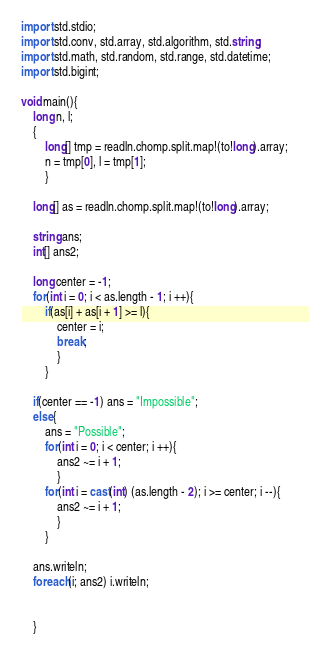Convert code to text. <code><loc_0><loc_0><loc_500><loc_500><_D_>import std.stdio;
import std.conv, std.array, std.algorithm, std.string;
import std.math, std.random, std.range, std.datetime;
import std.bigint;

void main(){
	long n, l;
	{
		long[] tmp = readln.chomp.split.map!(to!long).array;
		n = tmp[0], l = tmp[1];
		}
	
	long[] as = readln.chomp.split.map!(to!long).array;
	
	string ans;
	int[] ans2;
	
	long center = -1;
	for(int i = 0; i < as.length - 1; i ++){
		if(as[i] + as[i + 1] >= l){
			center = i;
			break;
			}
		}
	
	if(center == -1) ans = "Impossible";
	else{
		ans = "Possible";
		for(int i = 0; i < center; i ++){
			ans2 ~= i + 1;
			}
		for(int i = cast(int) (as.length - 2); i >= center; i --){
			ans2 ~= i + 1;
			}
		}
	
	ans.writeln;
	foreach(i; ans2) i.writeln;
	
	
	}</code> 